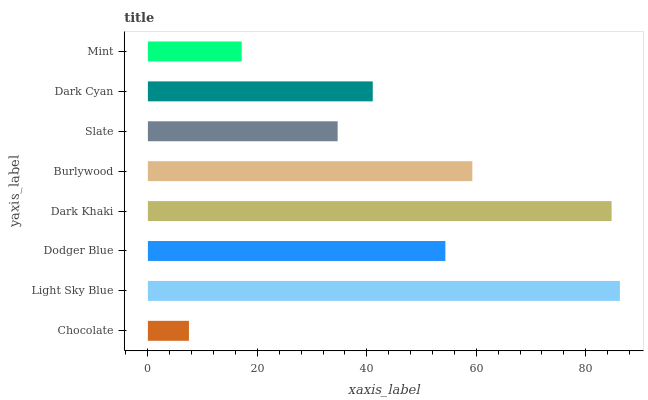Is Chocolate the minimum?
Answer yes or no. Yes. Is Light Sky Blue the maximum?
Answer yes or no. Yes. Is Dodger Blue the minimum?
Answer yes or no. No. Is Dodger Blue the maximum?
Answer yes or no. No. Is Light Sky Blue greater than Dodger Blue?
Answer yes or no. Yes. Is Dodger Blue less than Light Sky Blue?
Answer yes or no. Yes. Is Dodger Blue greater than Light Sky Blue?
Answer yes or no. No. Is Light Sky Blue less than Dodger Blue?
Answer yes or no. No. Is Dodger Blue the high median?
Answer yes or no. Yes. Is Dark Cyan the low median?
Answer yes or no. Yes. Is Dark Cyan the high median?
Answer yes or no. No. Is Dodger Blue the low median?
Answer yes or no. No. 